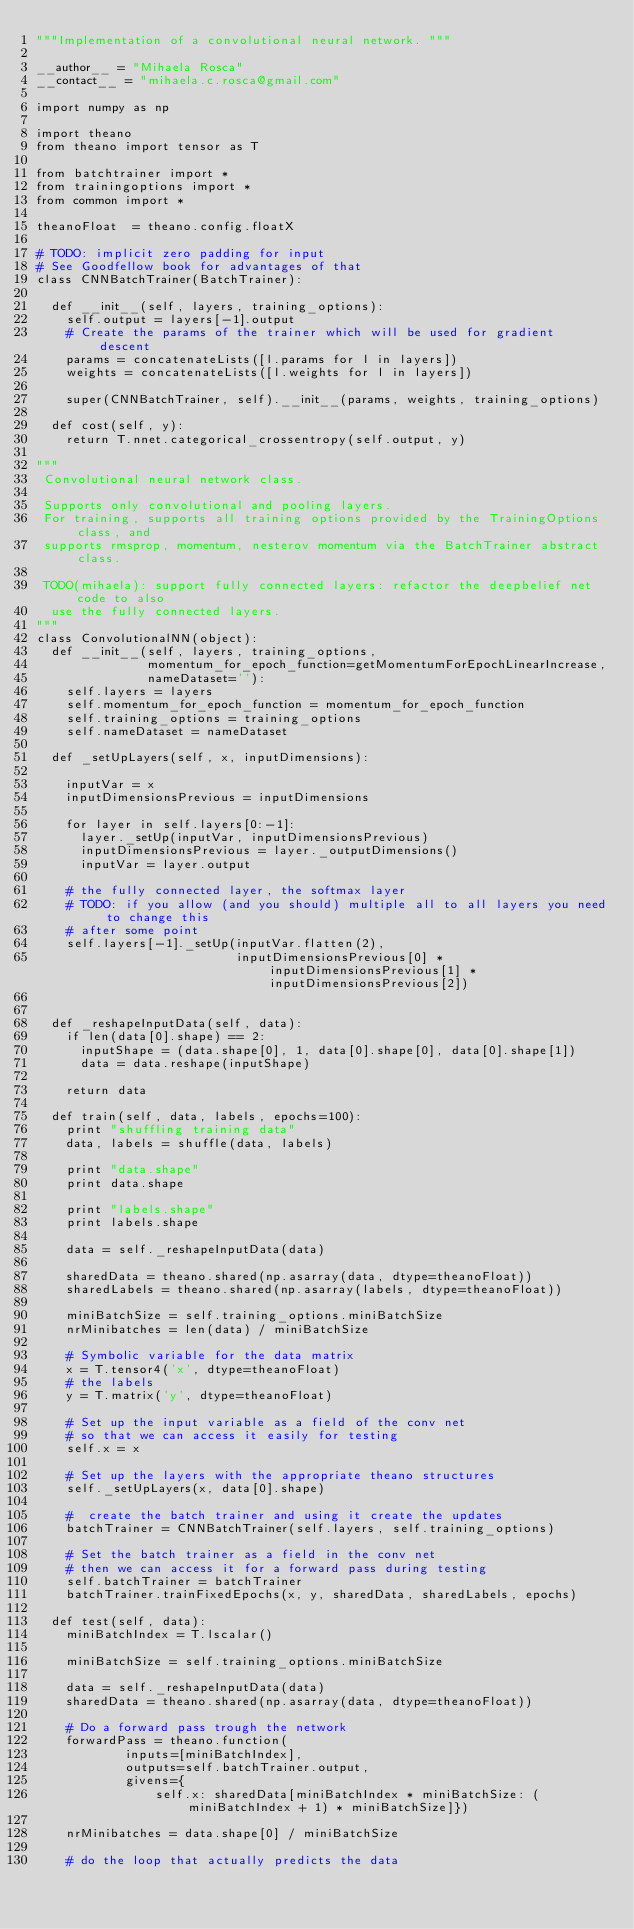<code> <loc_0><loc_0><loc_500><loc_500><_Python_>"""Implementation of a convolutional neural network. """

__author__ = "Mihaela Rosca"
__contact__ = "mihaela.c.rosca@gmail.com"

import numpy as np

import theano
from theano import tensor as T

from batchtrainer import *
from trainingoptions import *
from common import *

theanoFloat  = theano.config.floatX

# TODO: implicit zero padding for input
# See Goodfellow book for advantages of that
class CNNBatchTrainer(BatchTrainer):

  def __init__(self, layers, training_options):
    self.output = layers[-1].output
    # Create the params of the trainer which will be used for gradient descent
    params = concatenateLists([l.params for l in layers])
    weights = concatenateLists([l.weights for l in layers])

    super(CNNBatchTrainer, self).__init__(params, weights, training_options)

  def cost(self, y):
    return T.nnet.categorical_crossentropy(self.output, y)

"""
 Convolutional neural network class.

 Supports only convolutional and pooling layers.
 For training, supports all training options provided by the TrainingOptions class, and
 supports rmsprop, momentum, nesterov momentum via the BatchTrainer abstract class.

 TODO(mihaela): support fully connected layers: refactor the deepbelief net code to also
  use the fully connected layers.
"""
class ConvolutionalNN(object):
  def __init__(self, layers, training_options,
               momentum_for_epoch_function=getMomentumForEpochLinearIncrease,
               nameDataset=''):
    self.layers = layers
    self.momentum_for_epoch_function = momentum_for_epoch_function
    self.training_options = training_options
    self.nameDataset = nameDataset

  def _setUpLayers(self, x, inputDimensions):

    inputVar = x
    inputDimensionsPrevious = inputDimensions

    for layer in self.layers[0:-1]:
      layer._setUp(inputVar, inputDimensionsPrevious)
      inputDimensionsPrevious = layer._outputDimensions()
      inputVar = layer.output

    # the fully connected layer, the softmax layer
    # TODO: if you allow (and you should) multiple all to all layers you need to change this
    # after some point
    self.layers[-1]._setUp(inputVar.flatten(2),
                           inputDimensionsPrevious[0] * inputDimensionsPrevious[1] * inputDimensionsPrevious[2])


  def _reshapeInputData(self, data):
    if len(data[0].shape) == 2:
      inputShape = (data.shape[0], 1, data[0].shape[0], data[0].shape[1])
      data = data.reshape(inputShape)

    return data

  def train(self, data, labels, epochs=100):
    print "shuffling training data"
    data, labels = shuffle(data, labels)

    print "data.shape"
    print data.shape

    print "labels.shape"
    print labels.shape

    data = self._reshapeInputData(data)

    sharedData = theano.shared(np.asarray(data, dtype=theanoFloat))
    sharedLabels = theano.shared(np.asarray(labels, dtype=theanoFloat))

    miniBatchSize = self.training_options.miniBatchSize
    nrMinibatches = len(data) / miniBatchSize

    # Symbolic variable for the data matrix
    x = T.tensor4('x', dtype=theanoFloat)
    # the labels
    y = T.matrix('y', dtype=theanoFloat)

    # Set up the input variable as a field of the conv net
    # so that we can access it easily for testing
    self.x = x

    # Set up the layers with the appropriate theano structures
    self._setUpLayers(x, data[0].shape)

    #  create the batch trainer and using it create the updates
    batchTrainer = CNNBatchTrainer(self.layers, self.training_options)

    # Set the batch trainer as a field in the conv net
    # then we can access it for a forward pass during testing
    self.batchTrainer = batchTrainer
    batchTrainer.trainFixedEpochs(x, y, sharedData, sharedLabels, epochs)

  def test(self, data):
    miniBatchIndex = T.lscalar()

    miniBatchSize = self.training_options.miniBatchSize

    data = self._reshapeInputData(data)
    sharedData = theano.shared(np.asarray(data, dtype=theanoFloat))

    # Do a forward pass trough the network
    forwardPass = theano.function(
            inputs=[miniBatchIndex],
            outputs=self.batchTrainer.output,
            givens={
                self.x: sharedData[miniBatchIndex * miniBatchSize: (miniBatchIndex + 1) * miniBatchSize]})

    nrMinibatches = data.shape[0] / miniBatchSize

    # do the loop that actually predicts the data</code> 